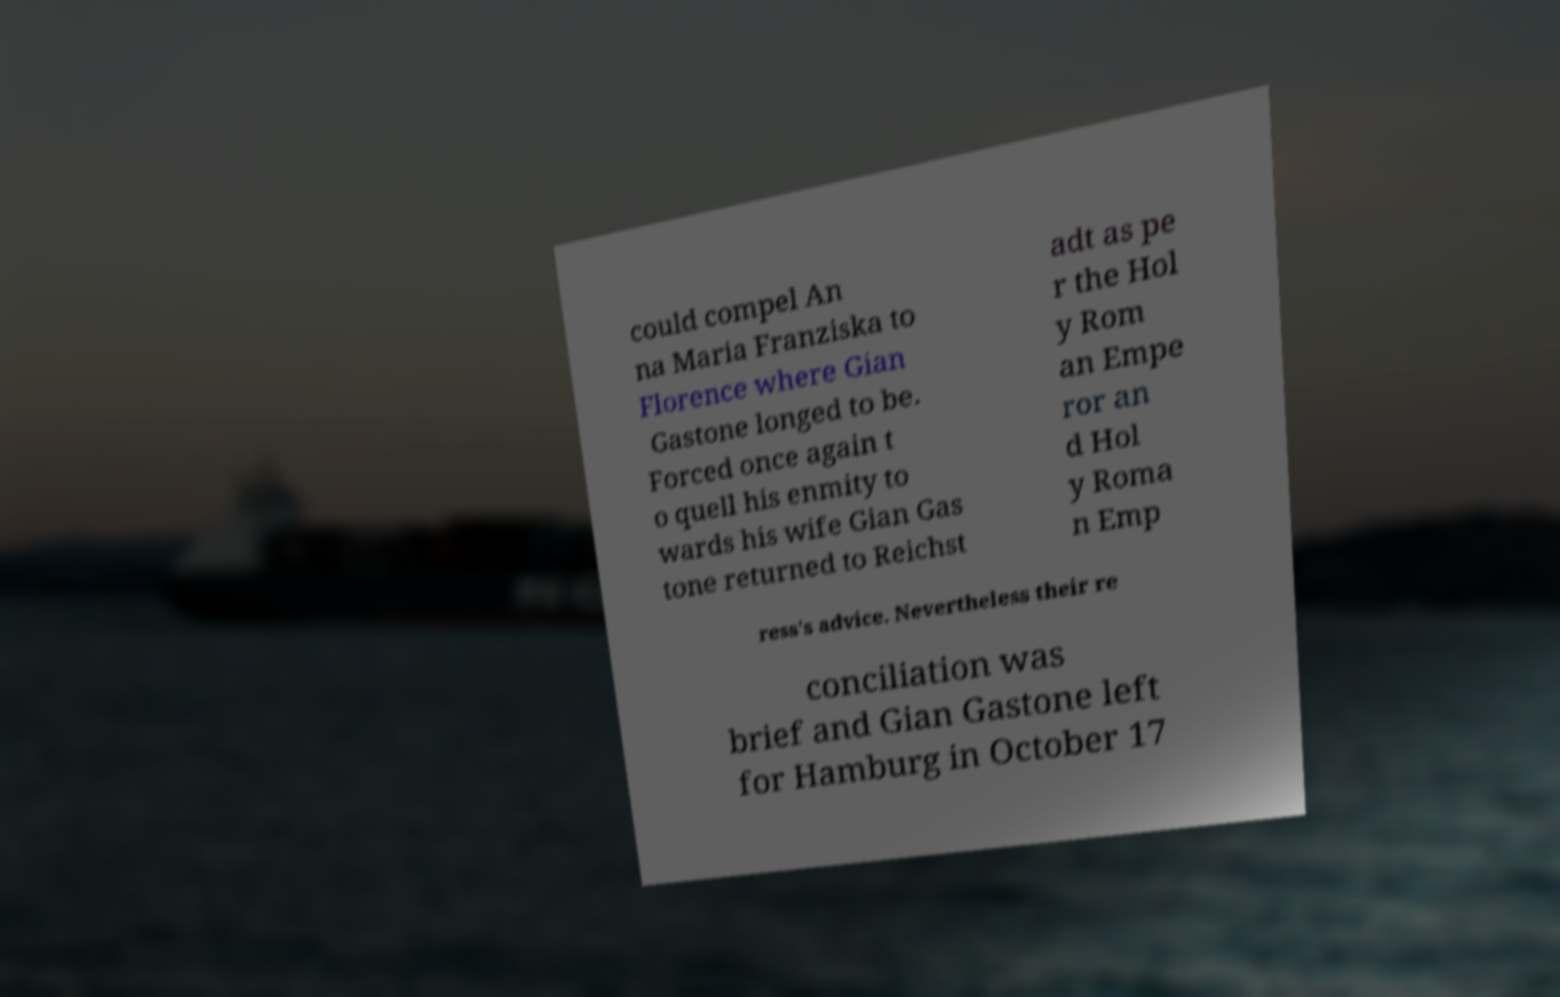There's text embedded in this image that I need extracted. Can you transcribe it verbatim? could compel An na Maria Franziska to Florence where Gian Gastone longed to be. Forced once again t o quell his enmity to wards his wife Gian Gas tone returned to Reichst adt as pe r the Hol y Rom an Empe ror an d Hol y Roma n Emp ress's advice. Nevertheless their re conciliation was brief and Gian Gastone left for Hamburg in October 17 